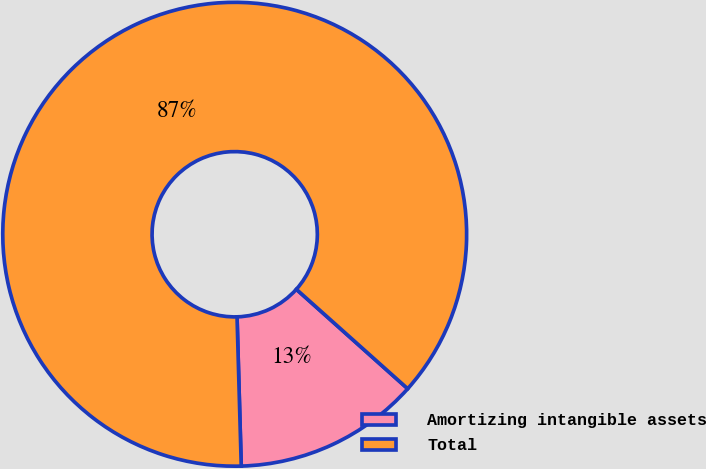<chart> <loc_0><loc_0><loc_500><loc_500><pie_chart><fcel>Amortizing intangible assets<fcel>Total<nl><fcel>12.95%<fcel>87.05%<nl></chart> 